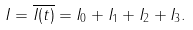Convert formula to latex. <formula><loc_0><loc_0><loc_500><loc_500>I = \overline { I ( t ) } = I _ { 0 } + I _ { 1 } + I _ { 2 } + I _ { 3 } .</formula> 